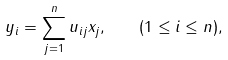<formula> <loc_0><loc_0><loc_500><loc_500>y _ { i } = \sum _ { j = 1 } ^ { n } u _ { i j } x _ { j } , \quad ( 1 \leq i \leq n ) ,</formula> 